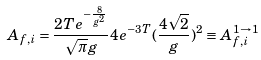Convert formula to latex. <formula><loc_0><loc_0><loc_500><loc_500>A _ { f , i } = \frac { 2 T e ^ { - \frac { 8 } { g ^ { 2 } } } } { \sqrt { \pi } g } 4 e ^ { - 3 T } ( \frac { 4 \sqrt { 2 } } { g } ) ^ { 2 } \equiv A _ { f , i } ^ { 1 \rightarrow 1 }</formula> 